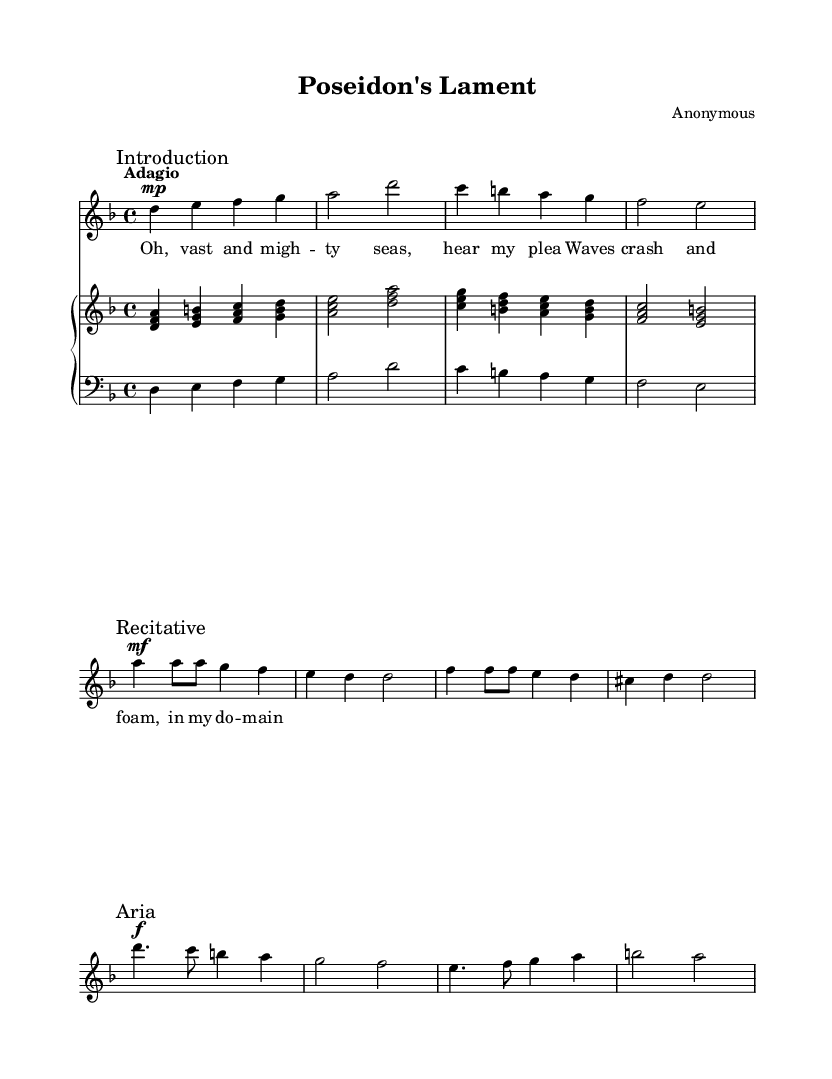What key is this music in? The key signature indicated on the sheet music is D minor, which has a B flat. This can be confirmed by looking at the key signature placed at the beginning of the staff.
Answer: D minor What is the time signature? The time signature shown in the sheet music is 4/4, meaning there are four beats per measure and a quarter note receives one beat. This is indicated at the beginning of the score.
Answer: 4/4 What is the tempo marking? The tempo indicated in the sheet music is "Adagio," which denotes a slow and leisurely pace. It is explicitly stated at the beginning of the score.
Answer: Adagio How many bars are in the introduction? The introduction section includes a total of four bars, as can be determined by counting the measures from the start of the piece to the end of the introduction section.
Answer: Four bars What dynamic marking is used for the recitative? The dynamic marking for the recitative section is mezzo-forte, indicated by "mf" next to the notes in that section.
Answer: Mezzo-forte What is the primary theme of the aria? The primary theme of the aria revolves around the imagery of waves crashing and foaming, as expressed in the lyrics during that section of the music.
Answer: Waves crashing How does the music represent a mythological story? The music portrays a mythological story through the use of vocal expressions and instrumental accompaniment that evokes the essence of water deities and their domains, as captured in the lyrics and overall thematic elements.
Answer: Water deities 